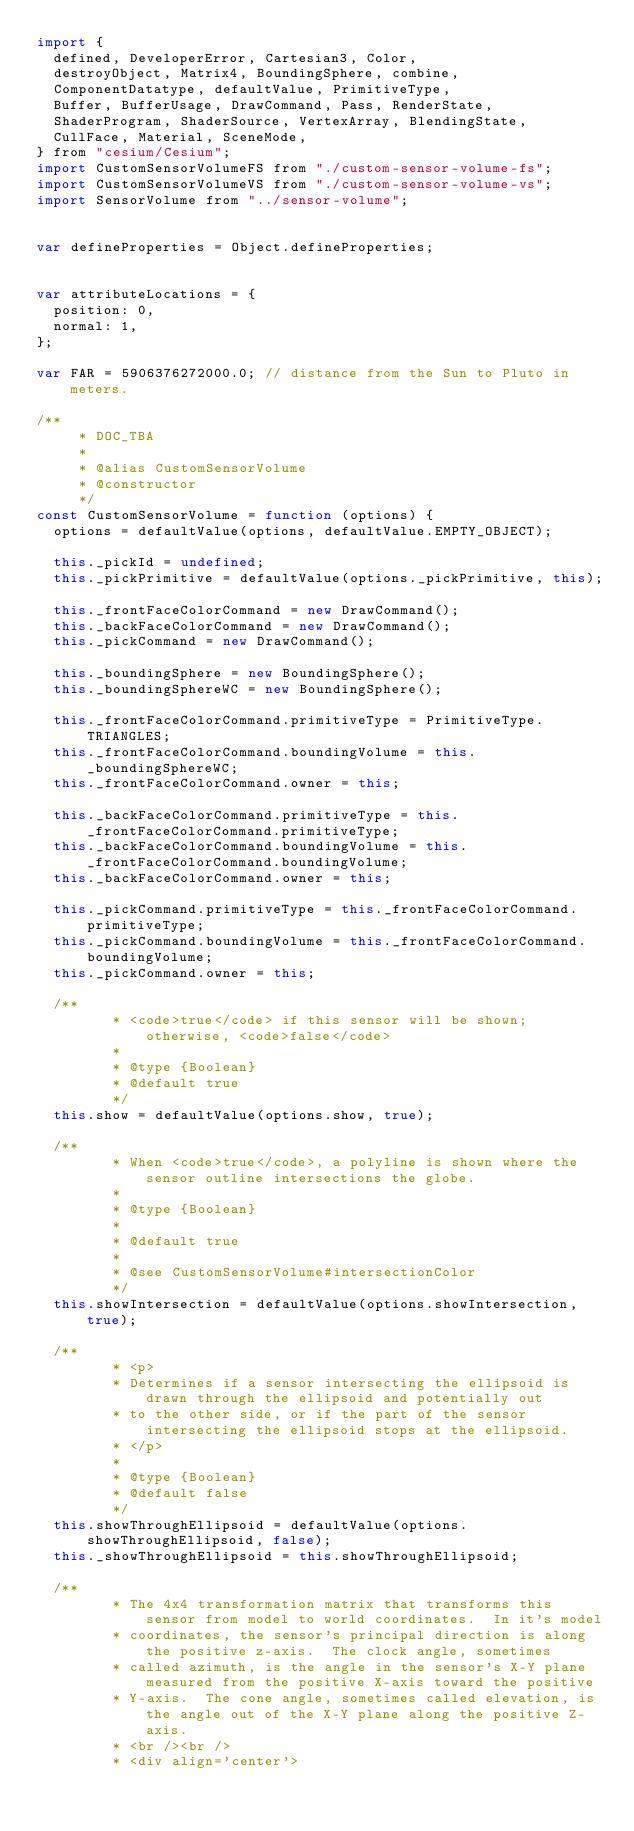Convert code to text. <code><loc_0><loc_0><loc_500><loc_500><_JavaScript_>import {
  defined, DeveloperError, Cartesian3, Color,
  destroyObject, Matrix4, BoundingSphere, combine,
  ComponentDatatype, defaultValue, PrimitiveType,
  Buffer, BufferUsage, DrawCommand, Pass, RenderState,
  ShaderProgram, ShaderSource, VertexArray, BlendingState,
  CullFace, Material, SceneMode,
} from "cesium/Cesium";
import CustomSensorVolumeFS from "./custom-sensor-volume-fs";
import CustomSensorVolumeVS from "./custom-sensor-volume-vs";
import SensorVolume from "../sensor-volume";


var defineProperties = Object.defineProperties;


var attributeLocations = {
  position: 0,
  normal: 1,
};

var FAR = 5906376272000.0; // distance from the Sun to Pluto in meters.

/**
	 * DOC_TBA
	 *
	 * @alias CustomSensorVolume
	 * @constructor
	 */
const CustomSensorVolume = function (options) {
  options = defaultValue(options, defaultValue.EMPTY_OBJECT);

  this._pickId = undefined;
  this._pickPrimitive = defaultValue(options._pickPrimitive, this);

  this._frontFaceColorCommand = new DrawCommand();
  this._backFaceColorCommand = new DrawCommand();
  this._pickCommand = new DrawCommand();

  this._boundingSphere = new BoundingSphere();
  this._boundingSphereWC = new BoundingSphere();

  this._frontFaceColorCommand.primitiveType = PrimitiveType.TRIANGLES;
  this._frontFaceColorCommand.boundingVolume = this._boundingSphereWC;
  this._frontFaceColorCommand.owner = this;

  this._backFaceColorCommand.primitiveType = this._frontFaceColorCommand.primitiveType;
  this._backFaceColorCommand.boundingVolume = this._frontFaceColorCommand.boundingVolume;
  this._backFaceColorCommand.owner = this;

  this._pickCommand.primitiveType = this._frontFaceColorCommand.primitiveType;
  this._pickCommand.boundingVolume = this._frontFaceColorCommand.boundingVolume;
  this._pickCommand.owner = this;

  /**
		 * <code>true</code> if this sensor will be shown; otherwise, <code>false</code>
		 *
		 * @type {Boolean}
		 * @default true
		 */
  this.show = defaultValue(options.show, true);

  /**
		 * When <code>true</code>, a polyline is shown where the sensor outline intersections the globe.
		 *
		 * @type {Boolean}
		 *
		 * @default true
		 *
		 * @see CustomSensorVolume#intersectionColor
		 */
  this.showIntersection = defaultValue(options.showIntersection, true);

  /**
		 * <p>
		 * Determines if a sensor intersecting the ellipsoid is drawn through the ellipsoid and potentially out
		 * to the other side, or if the part of the sensor intersecting the ellipsoid stops at the ellipsoid.
		 * </p>
		 *
		 * @type {Boolean}
		 * @default false
		 */
  this.showThroughEllipsoid = defaultValue(options.showThroughEllipsoid, false);
  this._showThroughEllipsoid = this.showThroughEllipsoid;

  /**
		 * The 4x4 transformation matrix that transforms this sensor from model to world coordinates.  In it's model
		 * coordinates, the sensor's principal direction is along the positive z-axis.  The clock angle, sometimes
		 * called azimuth, is the angle in the sensor's X-Y plane measured from the positive X-axis toward the positive
		 * Y-axis.  The cone angle, sometimes called elevation, is the angle out of the X-Y plane along the positive Z-axis.
		 * <br /><br />
		 * <div align='center'></code> 